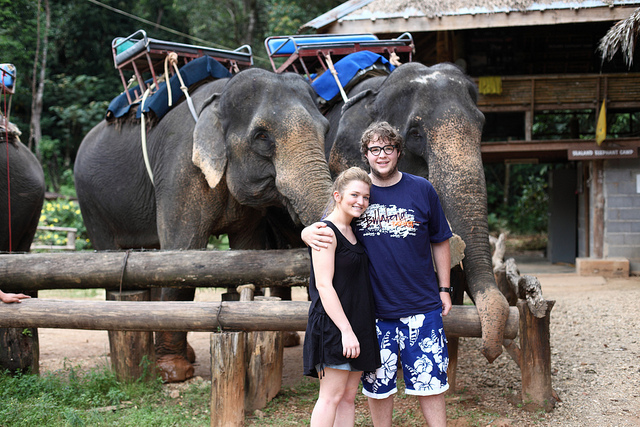Can you describe the two people in the photograph? Certainly, there's a young couple in the foreground of the photograph who seem to be tourists. They are smiling and looking directly at the camera, indicating that they are posing for a memorable photo with the elephants in the background. What can we infer about their experience? Based on their attire and the gear worn by the elephants, it seems likely that the couple has participated in, or is about to participate in, an elephant riding experience, which is a popular tourist activity in some countries. 